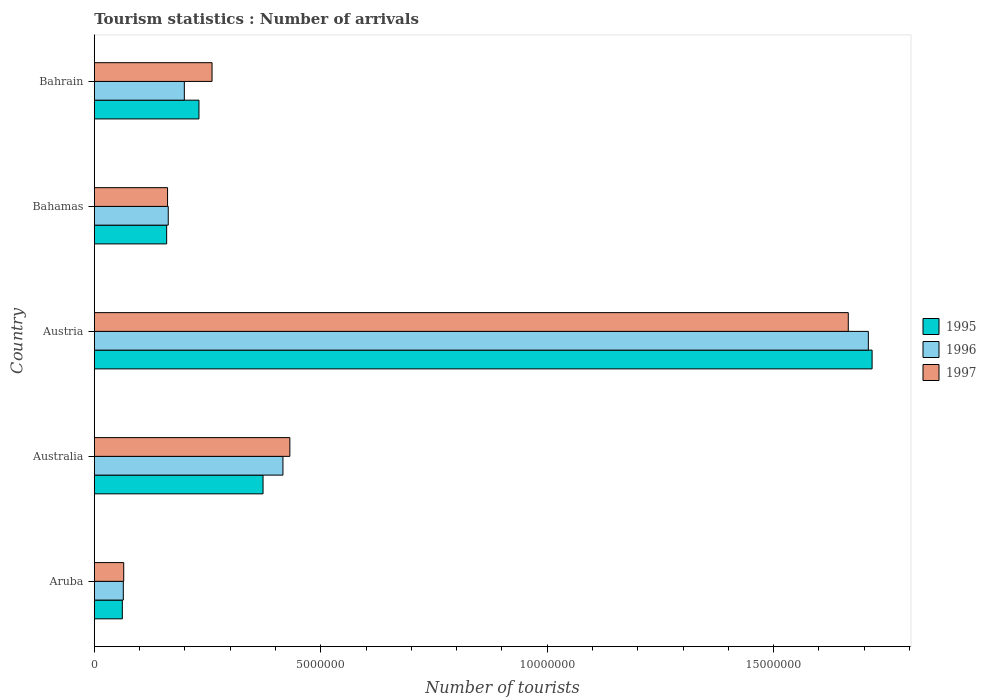How many different coloured bars are there?
Ensure brevity in your answer.  3. How many groups of bars are there?
Offer a very short reply. 5. Are the number of bars per tick equal to the number of legend labels?
Make the answer very short. Yes. Are the number of bars on each tick of the Y-axis equal?
Your answer should be compact. Yes. How many bars are there on the 1st tick from the top?
Your answer should be compact. 3. How many bars are there on the 5th tick from the bottom?
Offer a terse response. 3. What is the label of the 2nd group of bars from the top?
Offer a terse response. Bahamas. What is the number of tourist arrivals in 1995 in Bahrain?
Offer a very short reply. 2.31e+06. Across all countries, what is the maximum number of tourist arrivals in 1996?
Your answer should be compact. 1.71e+07. Across all countries, what is the minimum number of tourist arrivals in 1997?
Ensure brevity in your answer.  6.50e+05. In which country was the number of tourist arrivals in 1996 minimum?
Your response must be concise. Aruba. What is the total number of tourist arrivals in 1996 in the graph?
Keep it short and to the point. 2.55e+07. What is the difference between the number of tourist arrivals in 1995 in Australia and that in Bahamas?
Offer a very short reply. 2.13e+06. What is the difference between the number of tourist arrivals in 1997 in Bahrain and the number of tourist arrivals in 1996 in Austria?
Provide a succinct answer. -1.45e+07. What is the average number of tourist arrivals in 1997 per country?
Offer a very short reply. 5.17e+06. What is the difference between the number of tourist arrivals in 1996 and number of tourist arrivals in 1997 in Bahrain?
Provide a succinct answer. -6.12e+05. What is the ratio of the number of tourist arrivals in 1996 in Australia to that in Austria?
Your answer should be very brief. 0.24. What is the difference between the highest and the second highest number of tourist arrivals in 1996?
Your answer should be compact. 1.29e+07. What is the difference between the highest and the lowest number of tourist arrivals in 1996?
Ensure brevity in your answer.  1.64e+07. In how many countries, is the number of tourist arrivals in 1995 greater than the average number of tourist arrivals in 1995 taken over all countries?
Make the answer very short. 1. Is the sum of the number of tourist arrivals in 1995 in Aruba and Australia greater than the maximum number of tourist arrivals in 1997 across all countries?
Provide a short and direct response. No. What does the 2nd bar from the top in Australia represents?
Your response must be concise. 1996. Is it the case that in every country, the sum of the number of tourist arrivals in 1996 and number of tourist arrivals in 1997 is greater than the number of tourist arrivals in 1995?
Keep it short and to the point. Yes. How many bars are there?
Provide a succinct answer. 15. How many countries are there in the graph?
Keep it short and to the point. 5. What is the difference between two consecutive major ticks on the X-axis?
Offer a terse response. 5.00e+06. Does the graph contain any zero values?
Provide a short and direct response. No. How are the legend labels stacked?
Offer a very short reply. Vertical. What is the title of the graph?
Offer a terse response. Tourism statistics : Number of arrivals. What is the label or title of the X-axis?
Offer a terse response. Number of tourists. What is the Number of tourists in 1995 in Aruba?
Your answer should be compact. 6.19e+05. What is the Number of tourists in 1996 in Aruba?
Provide a succinct answer. 6.41e+05. What is the Number of tourists in 1997 in Aruba?
Provide a succinct answer. 6.50e+05. What is the Number of tourists in 1995 in Australia?
Provide a short and direct response. 3.73e+06. What is the Number of tourists of 1996 in Australia?
Your response must be concise. 4.16e+06. What is the Number of tourists of 1997 in Australia?
Your response must be concise. 4.32e+06. What is the Number of tourists of 1995 in Austria?
Offer a terse response. 1.72e+07. What is the Number of tourists of 1996 in Austria?
Provide a short and direct response. 1.71e+07. What is the Number of tourists in 1997 in Austria?
Your response must be concise. 1.66e+07. What is the Number of tourists of 1995 in Bahamas?
Give a very brief answer. 1.60e+06. What is the Number of tourists of 1996 in Bahamas?
Your response must be concise. 1.63e+06. What is the Number of tourists in 1997 in Bahamas?
Provide a short and direct response. 1.62e+06. What is the Number of tourists in 1995 in Bahrain?
Your answer should be compact. 2.31e+06. What is the Number of tourists of 1996 in Bahrain?
Give a very brief answer. 1.99e+06. What is the Number of tourists of 1997 in Bahrain?
Ensure brevity in your answer.  2.60e+06. Across all countries, what is the maximum Number of tourists in 1995?
Your answer should be very brief. 1.72e+07. Across all countries, what is the maximum Number of tourists of 1996?
Your answer should be compact. 1.71e+07. Across all countries, what is the maximum Number of tourists of 1997?
Make the answer very short. 1.66e+07. Across all countries, what is the minimum Number of tourists of 1995?
Keep it short and to the point. 6.19e+05. Across all countries, what is the minimum Number of tourists of 1996?
Keep it short and to the point. 6.41e+05. Across all countries, what is the minimum Number of tourists in 1997?
Give a very brief answer. 6.50e+05. What is the total Number of tourists of 1995 in the graph?
Offer a terse response. 2.54e+07. What is the total Number of tourists of 1996 in the graph?
Your answer should be compact. 2.55e+07. What is the total Number of tourists of 1997 in the graph?
Ensure brevity in your answer.  2.58e+07. What is the difference between the Number of tourists in 1995 in Aruba and that in Australia?
Make the answer very short. -3.11e+06. What is the difference between the Number of tourists of 1996 in Aruba and that in Australia?
Offer a terse response. -3.52e+06. What is the difference between the Number of tourists of 1997 in Aruba and that in Australia?
Keep it short and to the point. -3.67e+06. What is the difference between the Number of tourists in 1995 in Aruba and that in Austria?
Your answer should be very brief. -1.66e+07. What is the difference between the Number of tourists in 1996 in Aruba and that in Austria?
Provide a short and direct response. -1.64e+07. What is the difference between the Number of tourists of 1997 in Aruba and that in Austria?
Provide a succinct answer. -1.60e+07. What is the difference between the Number of tourists of 1995 in Aruba and that in Bahamas?
Your answer should be compact. -9.79e+05. What is the difference between the Number of tourists in 1996 in Aruba and that in Bahamas?
Provide a succinct answer. -9.92e+05. What is the difference between the Number of tourists in 1997 in Aruba and that in Bahamas?
Give a very brief answer. -9.68e+05. What is the difference between the Number of tourists of 1995 in Aruba and that in Bahrain?
Offer a terse response. -1.69e+06. What is the difference between the Number of tourists of 1996 in Aruba and that in Bahrain?
Ensure brevity in your answer.  -1.35e+06. What is the difference between the Number of tourists of 1997 in Aruba and that in Bahrain?
Offer a very short reply. -1.95e+06. What is the difference between the Number of tourists of 1995 in Australia and that in Austria?
Make the answer very short. -1.34e+07. What is the difference between the Number of tourists in 1996 in Australia and that in Austria?
Offer a terse response. -1.29e+07. What is the difference between the Number of tourists in 1997 in Australia and that in Austria?
Provide a short and direct response. -1.23e+07. What is the difference between the Number of tourists of 1995 in Australia and that in Bahamas?
Give a very brief answer. 2.13e+06. What is the difference between the Number of tourists of 1996 in Australia and that in Bahamas?
Ensure brevity in your answer.  2.53e+06. What is the difference between the Number of tourists in 1997 in Australia and that in Bahamas?
Provide a succinct answer. 2.70e+06. What is the difference between the Number of tourists in 1995 in Australia and that in Bahrain?
Your answer should be very brief. 1.42e+06. What is the difference between the Number of tourists in 1996 in Australia and that in Bahrain?
Give a very brief answer. 2.18e+06. What is the difference between the Number of tourists of 1997 in Australia and that in Bahrain?
Provide a succinct answer. 1.72e+06. What is the difference between the Number of tourists of 1995 in Austria and that in Bahamas?
Your answer should be very brief. 1.56e+07. What is the difference between the Number of tourists of 1996 in Austria and that in Bahamas?
Make the answer very short. 1.55e+07. What is the difference between the Number of tourists in 1997 in Austria and that in Bahamas?
Ensure brevity in your answer.  1.50e+07. What is the difference between the Number of tourists in 1995 in Austria and that in Bahrain?
Your response must be concise. 1.49e+07. What is the difference between the Number of tourists of 1996 in Austria and that in Bahrain?
Make the answer very short. 1.51e+07. What is the difference between the Number of tourists in 1997 in Austria and that in Bahrain?
Your answer should be compact. 1.40e+07. What is the difference between the Number of tourists in 1995 in Bahamas and that in Bahrain?
Keep it short and to the point. -7.13e+05. What is the difference between the Number of tourists in 1996 in Bahamas and that in Bahrain?
Give a very brief answer. -3.55e+05. What is the difference between the Number of tourists of 1997 in Bahamas and that in Bahrain?
Your answer should be very brief. -9.82e+05. What is the difference between the Number of tourists of 1995 in Aruba and the Number of tourists of 1996 in Australia?
Your answer should be compact. -3.55e+06. What is the difference between the Number of tourists in 1995 in Aruba and the Number of tourists in 1997 in Australia?
Offer a terse response. -3.70e+06. What is the difference between the Number of tourists of 1996 in Aruba and the Number of tourists of 1997 in Australia?
Offer a very short reply. -3.68e+06. What is the difference between the Number of tourists of 1995 in Aruba and the Number of tourists of 1996 in Austria?
Offer a very short reply. -1.65e+07. What is the difference between the Number of tourists in 1995 in Aruba and the Number of tourists in 1997 in Austria?
Offer a terse response. -1.60e+07. What is the difference between the Number of tourists in 1996 in Aruba and the Number of tourists in 1997 in Austria?
Your answer should be very brief. -1.60e+07. What is the difference between the Number of tourists in 1995 in Aruba and the Number of tourists in 1996 in Bahamas?
Provide a short and direct response. -1.01e+06. What is the difference between the Number of tourists of 1995 in Aruba and the Number of tourists of 1997 in Bahamas?
Provide a short and direct response. -9.99e+05. What is the difference between the Number of tourists of 1996 in Aruba and the Number of tourists of 1997 in Bahamas?
Offer a terse response. -9.77e+05. What is the difference between the Number of tourists of 1995 in Aruba and the Number of tourists of 1996 in Bahrain?
Make the answer very short. -1.37e+06. What is the difference between the Number of tourists of 1995 in Aruba and the Number of tourists of 1997 in Bahrain?
Your answer should be compact. -1.98e+06. What is the difference between the Number of tourists in 1996 in Aruba and the Number of tourists in 1997 in Bahrain?
Provide a succinct answer. -1.96e+06. What is the difference between the Number of tourists of 1995 in Australia and the Number of tourists of 1996 in Austria?
Provide a short and direct response. -1.34e+07. What is the difference between the Number of tourists of 1995 in Australia and the Number of tourists of 1997 in Austria?
Your answer should be very brief. -1.29e+07. What is the difference between the Number of tourists in 1996 in Australia and the Number of tourists in 1997 in Austria?
Offer a very short reply. -1.25e+07. What is the difference between the Number of tourists of 1995 in Australia and the Number of tourists of 1996 in Bahamas?
Offer a terse response. 2.09e+06. What is the difference between the Number of tourists of 1995 in Australia and the Number of tourists of 1997 in Bahamas?
Provide a succinct answer. 2.11e+06. What is the difference between the Number of tourists in 1996 in Australia and the Number of tourists in 1997 in Bahamas?
Ensure brevity in your answer.  2.55e+06. What is the difference between the Number of tourists of 1995 in Australia and the Number of tourists of 1996 in Bahrain?
Your answer should be compact. 1.74e+06. What is the difference between the Number of tourists of 1995 in Australia and the Number of tourists of 1997 in Bahrain?
Offer a very short reply. 1.13e+06. What is the difference between the Number of tourists in 1996 in Australia and the Number of tourists in 1997 in Bahrain?
Provide a short and direct response. 1.56e+06. What is the difference between the Number of tourists of 1995 in Austria and the Number of tourists of 1996 in Bahamas?
Offer a terse response. 1.55e+07. What is the difference between the Number of tourists of 1995 in Austria and the Number of tourists of 1997 in Bahamas?
Ensure brevity in your answer.  1.56e+07. What is the difference between the Number of tourists of 1996 in Austria and the Number of tourists of 1997 in Bahamas?
Your answer should be compact. 1.55e+07. What is the difference between the Number of tourists in 1995 in Austria and the Number of tourists in 1996 in Bahrain?
Provide a succinct answer. 1.52e+07. What is the difference between the Number of tourists of 1995 in Austria and the Number of tourists of 1997 in Bahrain?
Your answer should be very brief. 1.46e+07. What is the difference between the Number of tourists in 1996 in Austria and the Number of tourists in 1997 in Bahrain?
Your answer should be compact. 1.45e+07. What is the difference between the Number of tourists in 1995 in Bahamas and the Number of tourists in 1996 in Bahrain?
Give a very brief answer. -3.90e+05. What is the difference between the Number of tourists of 1995 in Bahamas and the Number of tourists of 1997 in Bahrain?
Offer a very short reply. -1.00e+06. What is the difference between the Number of tourists in 1996 in Bahamas and the Number of tourists in 1997 in Bahrain?
Your answer should be compact. -9.67e+05. What is the average Number of tourists in 1995 per country?
Offer a terse response. 5.09e+06. What is the average Number of tourists in 1996 per country?
Offer a very short reply. 5.10e+06. What is the average Number of tourists of 1997 per country?
Your answer should be compact. 5.17e+06. What is the difference between the Number of tourists of 1995 and Number of tourists of 1996 in Aruba?
Provide a succinct answer. -2.20e+04. What is the difference between the Number of tourists in 1995 and Number of tourists in 1997 in Aruba?
Give a very brief answer. -3.10e+04. What is the difference between the Number of tourists of 1996 and Number of tourists of 1997 in Aruba?
Provide a short and direct response. -9000. What is the difference between the Number of tourists in 1995 and Number of tourists in 1996 in Australia?
Make the answer very short. -4.39e+05. What is the difference between the Number of tourists in 1995 and Number of tourists in 1997 in Australia?
Provide a succinct answer. -5.92e+05. What is the difference between the Number of tourists in 1996 and Number of tourists in 1997 in Australia?
Your response must be concise. -1.53e+05. What is the difference between the Number of tourists of 1995 and Number of tourists of 1996 in Austria?
Offer a very short reply. 8.30e+04. What is the difference between the Number of tourists in 1995 and Number of tourists in 1997 in Austria?
Offer a terse response. 5.26e+05. What is the difference between the Number of tourists in 1996 and Number of tourists in 1997 in Austria?
Make the answer very short. 4.43e+05. What is the difference between the Number of tourists of 1995 and Number of tourists of 1996 in Bahamas?
Offer a terse response. -3.50e+04. What is the difference between the Number of tourists of 1996 and Number of tourists of 1997 in Bahamas?
Provide a short and direct response. 1.50e+04. What is the difference between the Number of tourists in 1995 and Number of tourists in 1996 in Bahrain?
Ensure brevity in your answer.  3.23e+05. What is the difference between the Number of tourists of 1995 and Number of tourists of 1997 in Bahrain?
Offer a very short reply. -2.89e+05. What is the difference between the Number of tourists of 1996 and Number of tourists of 1997 in Bahrain?
Give a very brief answer. -6.12e+05. What is the ratio of the Number of tourists in 1995 in Aruba to that in Australia?
Keep it short and to the point. 0.17. What is the ratio of the Number of tourists in 1996 in Aruba to that in Australia?
Your response must be concise. 0.15. What is the ratio of the Number of tourists of 1997 in Aruba to that in Australia?
Offer a terse response. 0.15. What is the ratio of the Number of tourists in 1995 in Aruba to that in Austria?
Your response must be concise. 0.04. What is the ratio of the Number of tourists of 1996 in Aruba to that in Austria?
Offer a terse response. 0.04. What is the ratio of the Number of tourists of 1997 in Aruba to that in Austria?
Provide a short and direct response. 0.04. What is the ratio of the Number of tourists in 1995 in Aruba to that in Bahamas?
Offer a terse response. 0.39. What is the ratio of the Number of tourists in 1996 in Aruba to that in Bahamas?
Provide a short and direct response. 0.39. What is the ratio of the Number of tourists in 1997 in Aruba to that in Bahamas?
Provide a short and direct response. 0.4. What is the ratio of the Number of tourists of 1995 in Aruba to that in Bahrain?
Make the answer very short. 0.27. What is the ratio of the Number of tourists of 1996 in Aruba to that in Bahrain?
Your response must be concise. 0.32. What is the ratio of the Number of tourists in 1997 in Aruba to that in Bahrain?
Offer a very short reply. 0.25. What is the ratio of the Number of tourists in 1995 in Australia to that in Austria?
Provide a short and direct response. 0.22. What is the ratio of the Number of tourists in 1996 in Australia to that in Austria?
Provide a succinct answer. 0.24. What is the ratio of the Number of tourists of 1997 in Australia to that in Austria?
Offer a very short reply. 0.26. What is the ratio of the Number of tourists of 1995 in Australia to that in Bahamas?
Offer a terse response. 2.33. What is the ratio of the Number of tourists of 1996 in Australia to that in Bahamas?
Make the answer very short. 2.55. What is the ratio of the Number of tourists of 1997 in Australia to that in Bahamas?
Make the answer very short. 2.67. What is the ratio of the Number of tourists of 1995 in Australia to that in Bahrain?
Offer a very short reply. 1.61. What is the ratio of the Number of tourists in 1996 in Australia to that in Bahrain?
Offer a very short reply. 2.1. What is the ratio of the Number of tourists in 1997 in Australia to that in Bahrain?
Your answer should be compact. 1.66. What is the ratio of the Number of tourists of 1995 in Austria to that in Bahamas?
Your answer should be compact. 10.75. What is the ratio of the Number of tourists in 1996 in Austria to that in Bahamas?
Offer a very short reply. 10.47. What is the ratio of the Number of tourists in 1997 in Austria to that in Bahamas?
Ensure brevity in your answer.  10.29. What is the ratio of the Number of tourists of 1995 in Austria to that in Bahrain?
Provide a succinct answer. 7.43. What is the ratio of the Number of tourists of 1996 in Austria to that in Bahrain?
Offer a very short reply. 8.6. What is the ratio of the Number of tourists in 1997 in Austria to that in Bahrain?
Your answer should be very brief. 6.4. What is the ratio of the Number of tourists in 1995 in Bahamas to that in Bahrain?
Ensure brevity in your answer.  0.69. What is the ratio of the Number of tourists of 1996 in Bahamas to that in Bahrain?
Ensure brevity in your answer.  0.82. What is the ratio of the Number of tourists of 1997 in Bahamas to that in Bahrain?
Keep it short and to the point. 0.62. What is the difference between the highest and the second highest Number of tourists of 1995?
Your answer should be very brief. 1.34e+07. What is the difference between the highest and the second highest Number of tourists in 1996?
Offer a very short reply. 1.29e+07. What is the difference between the highest and the second highest Number of tourists of 1997?
Ensure brevity in your answer.  1.23e+07. What is the difference between the highest and the lowest Number of tourists in 1995?
Your answer should be very brief. 1.66e+07. What is the difference between the highest and the lowest Number of tourists in 1996?
Provide a short and direct response. 1.64e+07. What is the difference between the highest and the lowest Number of tourists of 1997?
Your answer should be very brief. 1.60e+07. 